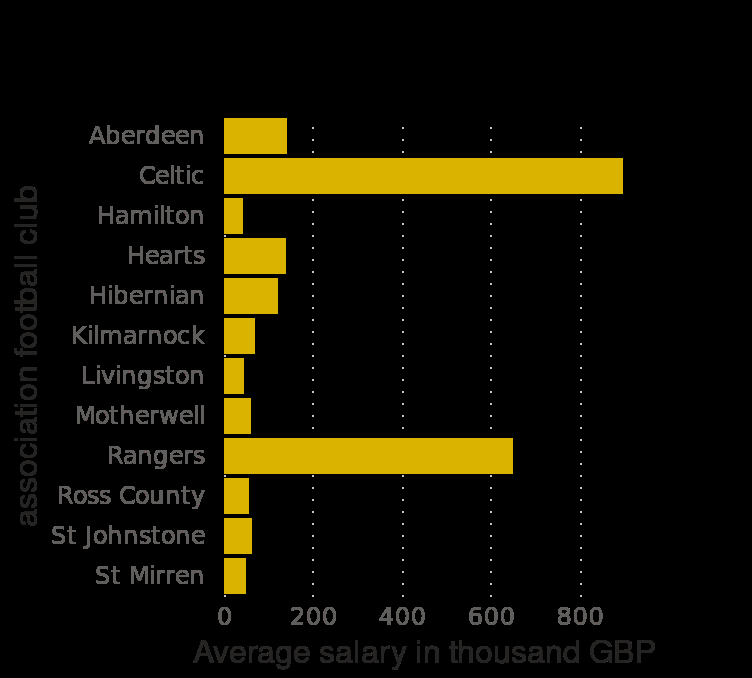<image>
What is the name of the bar chart?  The bar chart is called Average annual first-team player salary in the Scottish Premiership in Scotland in 2019/2020, by football club (in 1,000 GBP). What is the scale along the y-axis of the bar chart?  The scale along the y-axis is a categorical scale from Aberdeen to [unknown club name], marked association football club. Do Celtic and Rangers players earn significantly more than players in other clubs in the Scottish premiership?  Yes, Celtic and Rangers players earn significantly more than players in other clubs in the Scottish premiership. Which Scottish club has the lowest average earnings for its players?  Hamilton has the lowest average earnings for its players. 